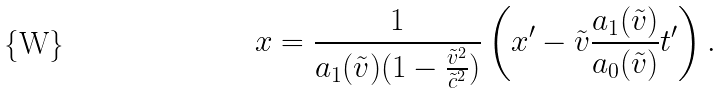Convert formula to latex. <formula><loc_0><loc_0><loc_500><loc_500>x = \frac { 1 } { a _ { 1 } ( \tilde { v } ) ( 1 - \frac { \tilde { v } ^ { 2 } } { \tilde { c } ^ { 2 } } ) } \left ( x ^ { \prime } - \tilde { v } \frac { a _ { 1 } ( \tilde { v } ) } { a _ { 0 } ( \tilde { v } ) } t ^ { \prime } \right ) .</formula> 